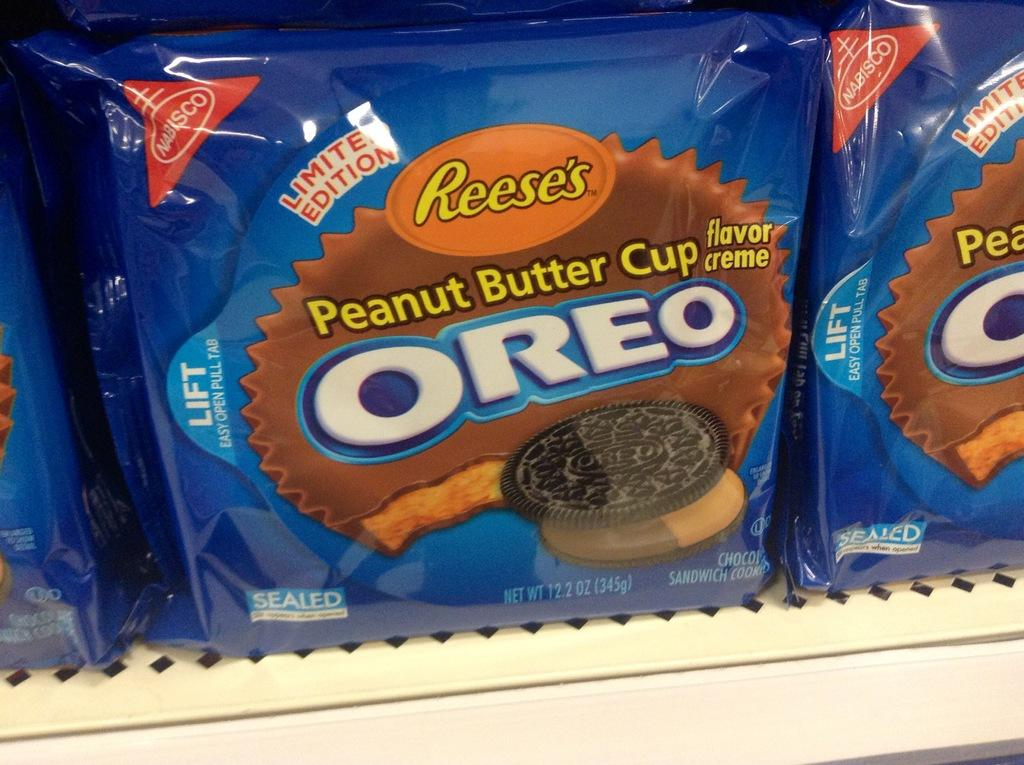What is the main subject of the image? The main subject of the image is a biscuit packet. What brand of biscuits is in the packet? The biscuit packet has "Oreo" written on it. Where is the biscuit packet located in the image? The biscuit packet is placed in a rack. What type of bead is used to decorate the biscuit packet in the image? There is no bead present on the biscuit packet in the image. What is the condition of the biscuit packet in the image? The condition of the biscuit packet cannot be determined from the image alone, as it only shows the packet and its placement in a rack. 